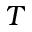Convert formula to latex. <formula><loc_0><loc_0><loc_500><loc_500>T</formula> 